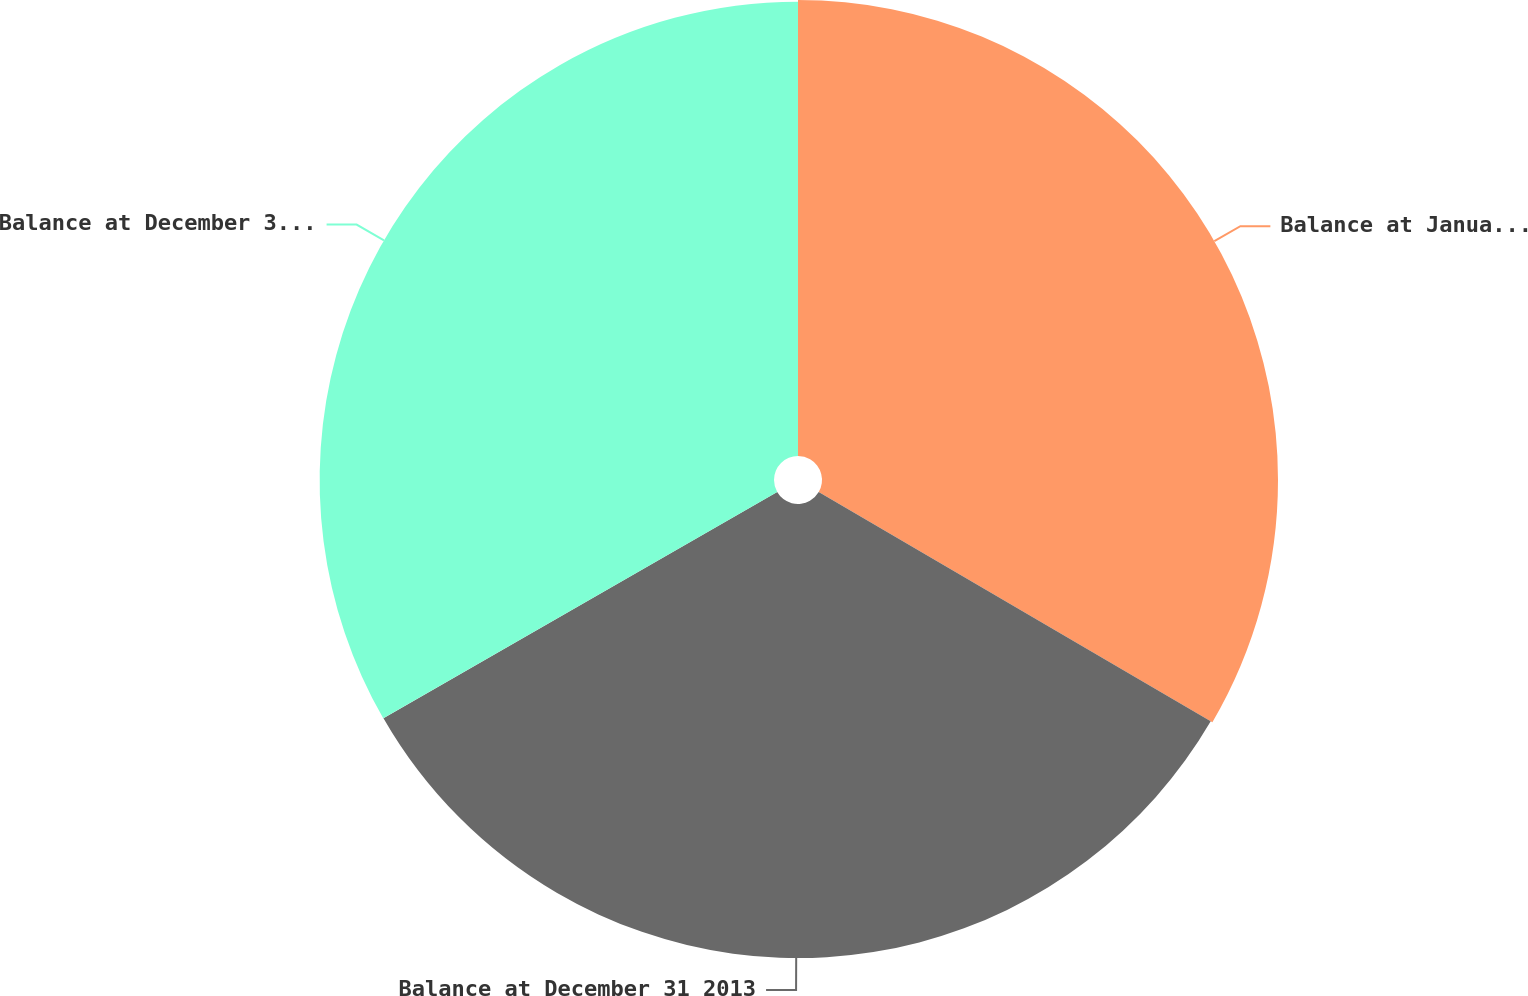Convert chart. <chart><loc_0><loc_0><loc_500><loc_500><pie_chart><fcel>Balance at January 1 2013<fcel>Balance at December 31 2013<fcel>Balance at December 31 2014<nl><fcel>33.42%<fcel>33.28%<fcel>33.3%<nl></chart> 